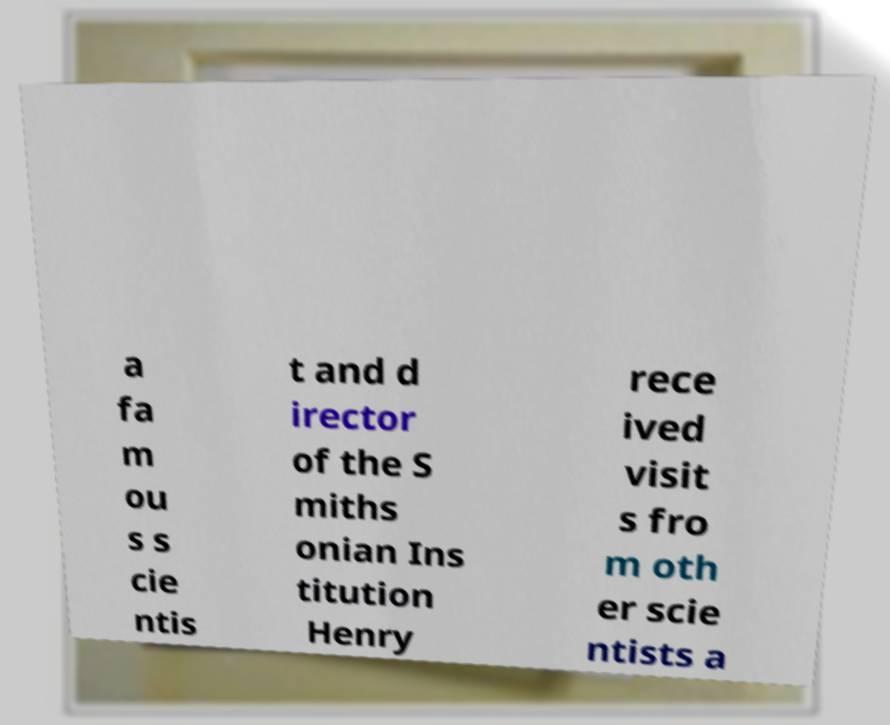Could you assist in decoding the text presented in this image and type it out clearly? a fa m ou s s cie ntis t and d irector of the S miths onian Ins titution Henry rece ived visit s fro m oth er scie ntists a 